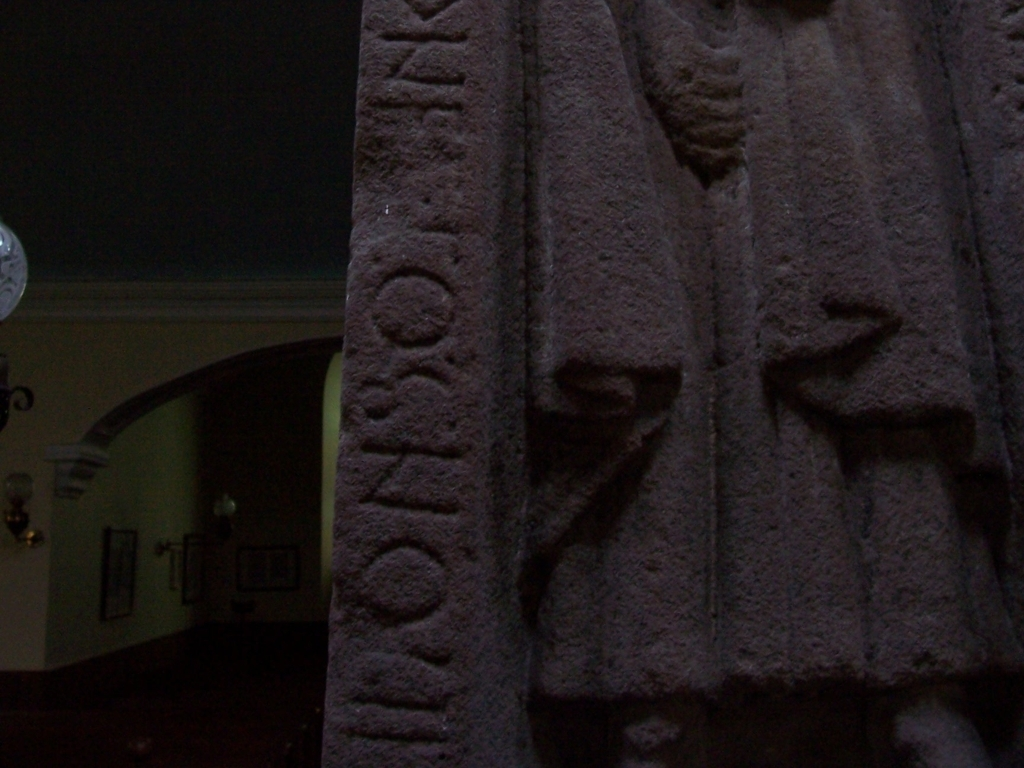Could the condition of these carvings tell us something about how they've been preserved? Yes, the overall condition of the carvings indicates that they've been reasonably well-preserved, considering their likely age. Factors contributing to their preservation may include the properties of the stone, environmental conditions, and any conservation efforts. The discernible wear suggests exposure to the elements or human contact, but the markings are resilient enough to remain visible. 